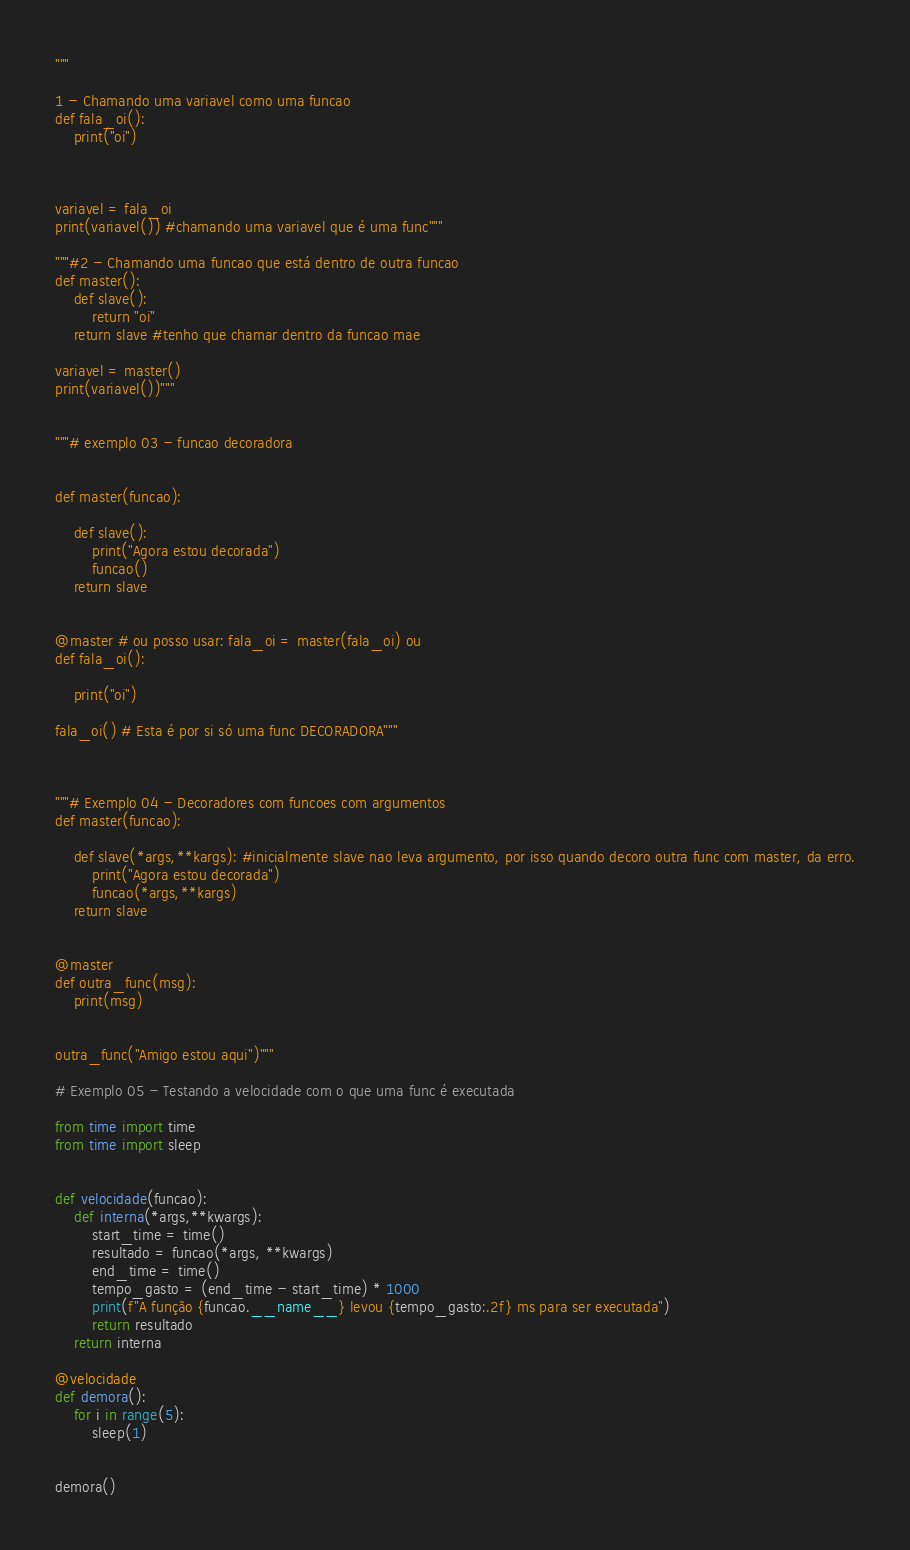Convert code to text. <code><loc_0><loc_0><loc_500><loc_500><_Python_>"""

1 - Chamando uma variavel como uma funcao
def fala_oi():
    print("oi")
    


variavel = fala_oi
print(variavel()) #chamando uma variavel que é uma func"""

"""#2 - Chamando uma funcao que está dentro de outra funcao
def master():
    def slave():
        return "oi"
    return slave #tenho que chamar dentro da funcao mae

variavel = master()
print(variavel())"""


"""# exemplo 03 - funcao decoradora


def master(funcao):
    
    def slave():
        print("Agora estou decorada")
        funcao()
    return slave


@master # ou posso usar: fala_oi = master(fala_oi) ou 
def fala_oi():

    print("oi")

fala_oi() # Esta é por si só uma func DECORADORA"""



"""# Exemplo 04 - Decoradores com funcoes com argumentos
def master(funcao):
    
    def slave(*args,**kargs): #inicialmente slave nao leva argumento, por isso quando decoro outra func com master, da erro.
        print("Agora estou decorada")
        funcao(*args,**kargs)
    return slave


@master
def outra_func(msg):
    print(msg)


outra_func("Amigo estou aqui")"""

# Exemplo 05 - Testando a velocidade com o que uma func é executada

from time import time
from time import sleep


def velocidade(funcao):
    def interna(*args,**kwargs):
        start_time = time()
        resultado = funcao(*args, **kwargs)
        end_time = time()
        tempo_gasto = (end_time - start_time) * 1000
        print(f"A função {funcao.__name__} levou {tempo_gasto:.2f} ms para ser executada")
        return resultado
    return interna

@velocidade
def demora():
    for i in range(5):
        sleep(1)


demora()
</code> 